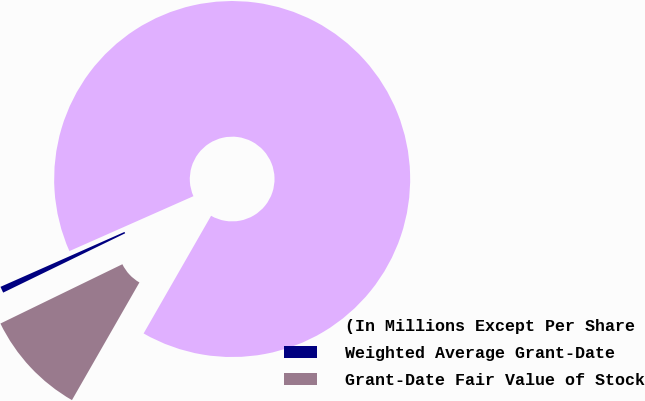Convert chart to OTSL. <chart><loc_0><loc_0><loc_500><loc_500><pie_chart><fcel>(In Millions Except Per Share<fcel>Weighted Average Grant-Date<fcel>Grant-Date Fair Value of Stock<nl><fcel>89.92%<fcel>0.57%<fcel>9.51%<nl></chart> 